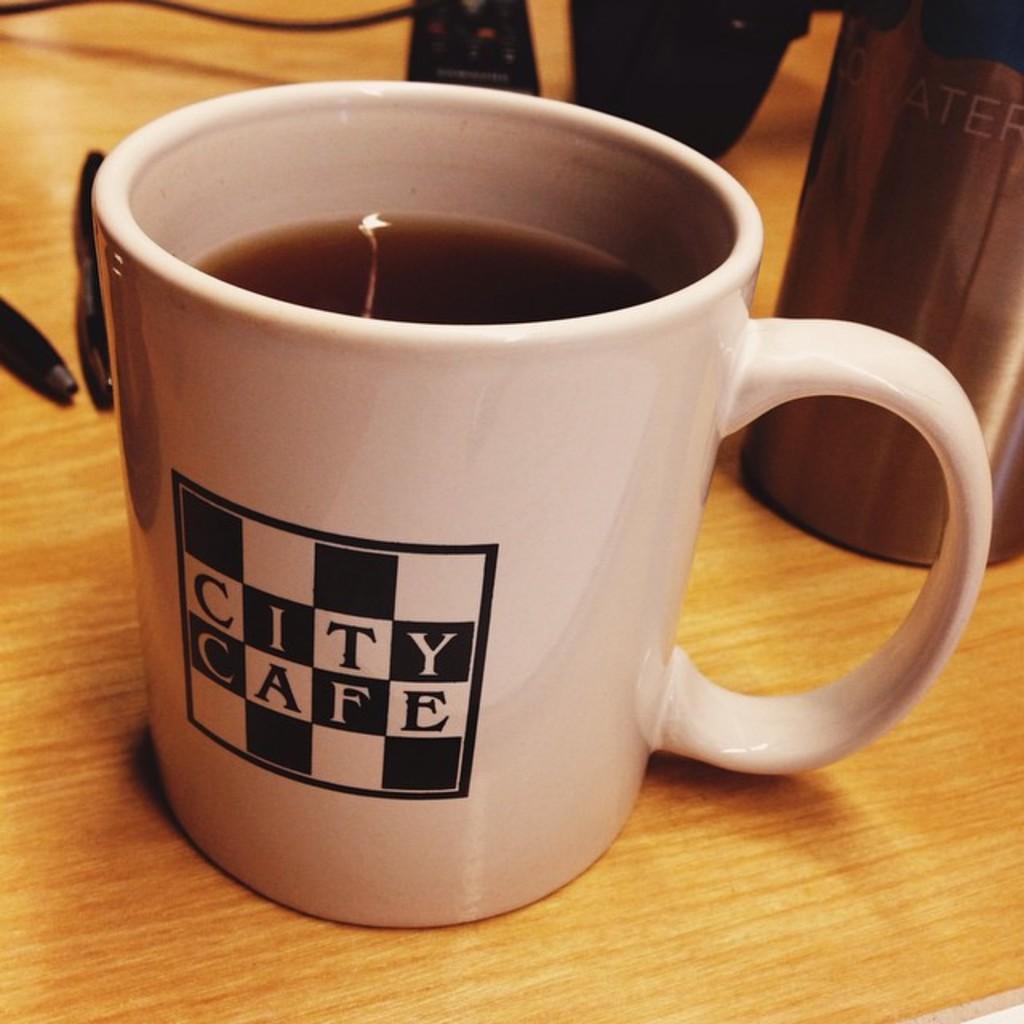How would you summarize this image in a sentence or two? In this image there is a coffee in the cup. Beside the cup there are pens and a few other objects on the table. 